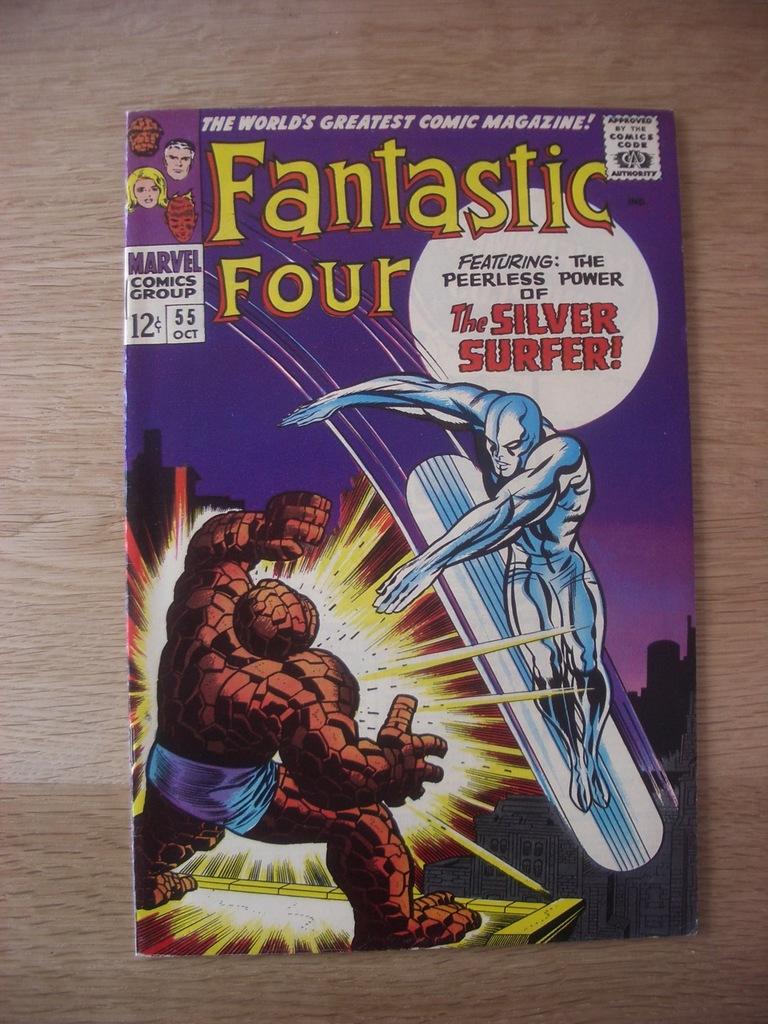What is the title of the book?
Keep it short and to the point. Fantastic four. 